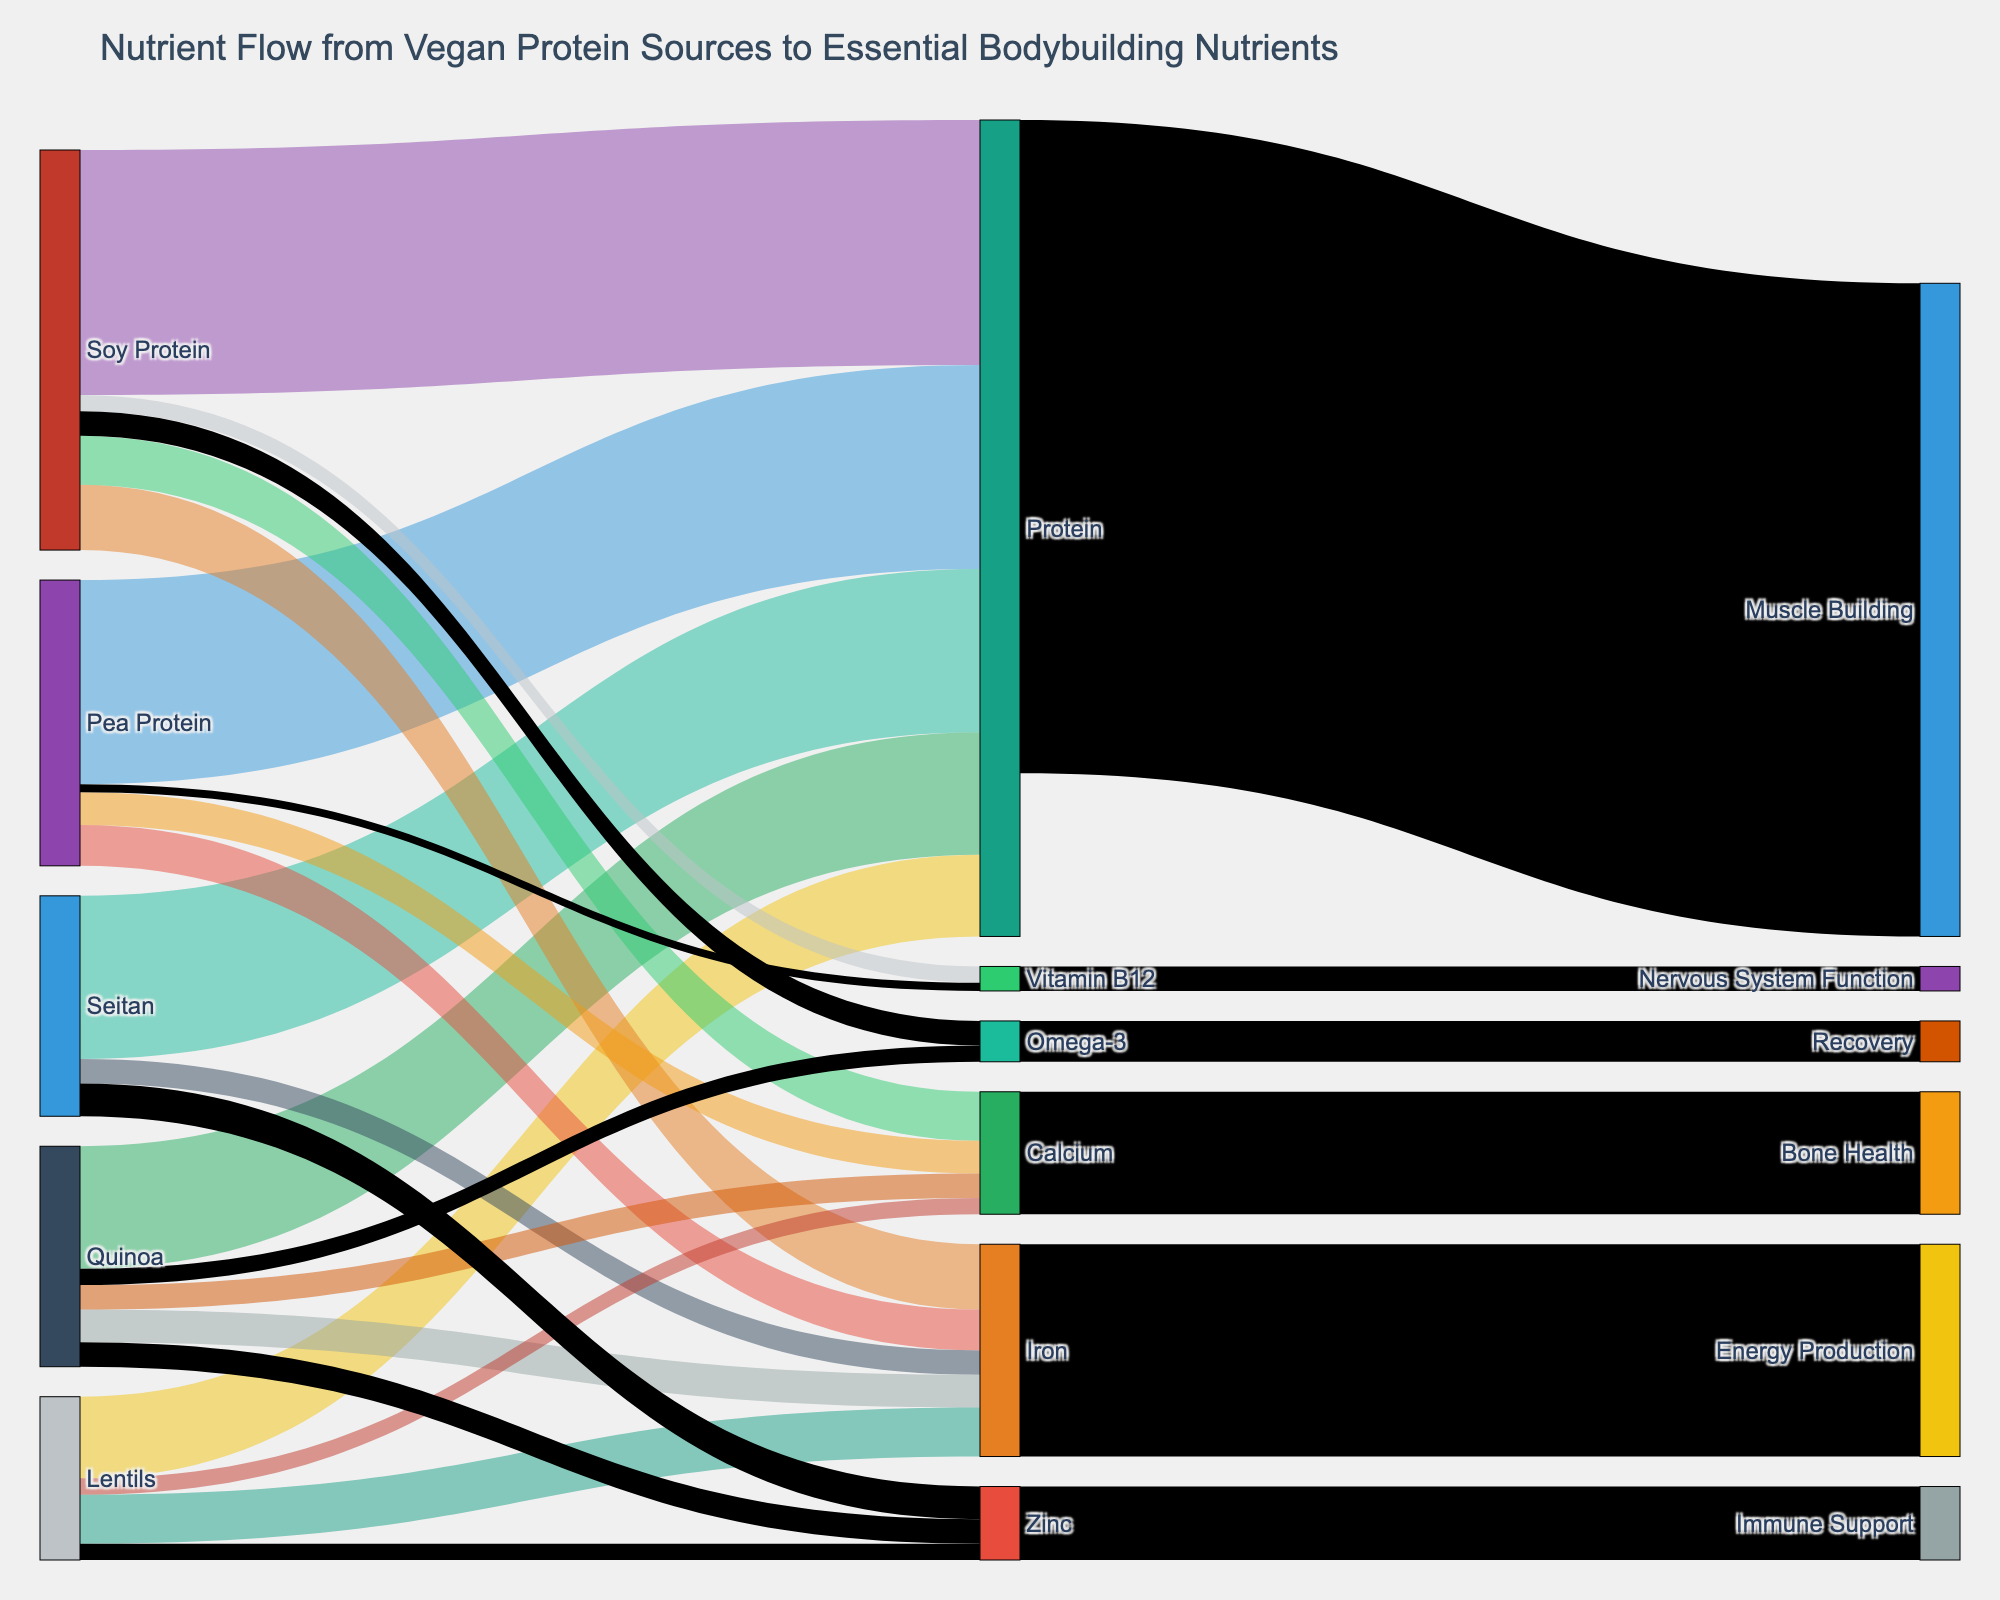What is the total amount of protein from all vegan sources as shown in the diagram? Sum the values for protein contributions from Soy Protein, Pea Protein, Seitan, Quinoa, and Lentils: 30 + 25 + 20 + 15 + 10.
Answer: 100 Which vegan protein source contributes the most to iron intake? Identify the highest value among the contributions to iron: 8 from Soy Protein.
Answer: Soy Protein Compare the contributions of Soy Protein and Quinoa to calcium intake. Which one is higher? Look at the calcium contributions: Soy Protein (6) vs. Quinoa (3).
Answer: Soy Protein How much of the total protein flow is dedicated to muscle building? According to the diagram, the entire protein flow (80) is allocated to Muscle Building.
Answer: 80 What is the combined contribution of Pea Protein and Lentils to Vitamin B12? Sum the values for Vitamin B12 contributions from Pea Protein (1) and Lentils (0).
Answer: 1 Identify two vegan protein sources that do not contribute to Zinc intake. Examine the Zinc flows and note that Soy Protein, Pea Protein, and Quinoa contribute (4, 3, 2 respectively), while Lentils and Seitan do not.
Answer: Soy Protein, Pea Protein How does Soy Protein's contribution to Omega-3 compare with its contribution to Vitamin B12? Compare the values: Omega-3 (3) and Vitamin B12 (2).
Answer: Omega-3 is higher What is the total contribution of all sources to Energy Production? Sum contributions to Iron: Soy Protein (8), Pea Protein (5), Seitan (3), Quinoa (4), Lentils (6) and then sum the total 26.
Answer: 26 How many essential bodybuilding nutrients are Soy Protein contributing to in the diagram? Count the targets from Soy Protein: Protein, Iron, Calcium, Vitamin B12, Omega-3 (5 targets).
Answer: 5 Which nutrient related to the Nervous System Function is shown in the diagram and from which sources does it come? The nutrient is Vitamin B12, which comes from Soy Protein (2) and Pea Protein (1).
Answer: Vitamin B12 from Soy and Pea Protein 